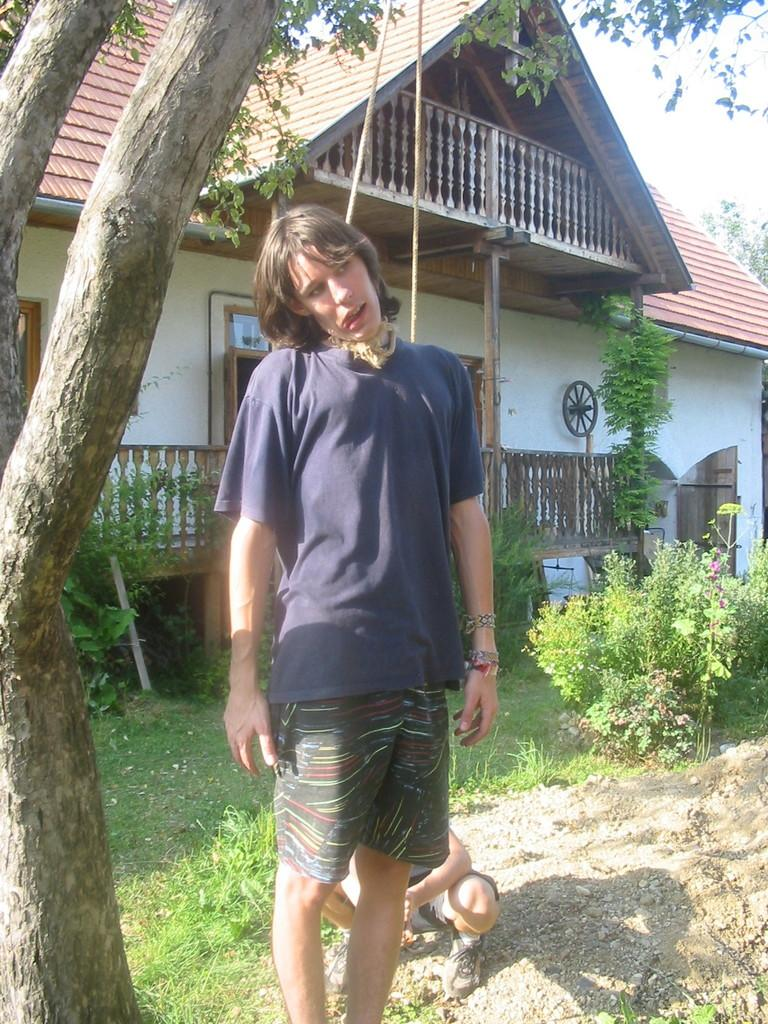How many people are in the image? There are two people in the image. What type of vegetation can be seen in the image? There is a tree, grass, plants, and flowers in the image. What type of structure is present in the image? There is a house in the image. What architectural feature can be seen in the image? There is a railing in the image. What other objects can be seen in the image? There are ropes in the image. What can be seen in the background of the image? The sky is visible in the background of the image. Who is the creator of the fan in the image? There is no fan present in the image. What type of drawer is visible in the image? There is no drawer present in the image. 